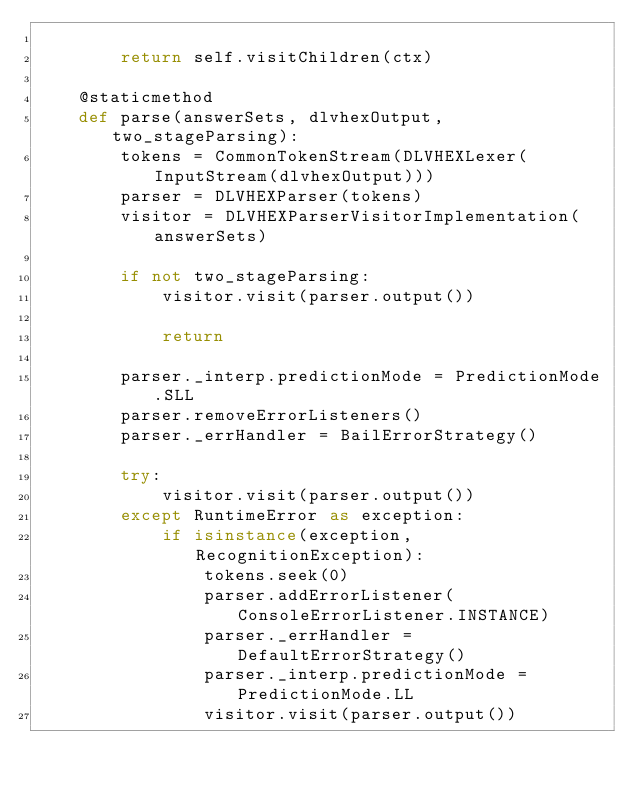Convert code to text. <code><loc_0><loc_0><loc_500><loc_500><_Python_>
        return self.visitChildren(ctx)

    @staticmethod
    def parse(answerSets, dlvhexOutput, two_stageParsing):
        tokens = CommonTokenStream(DLVHEXLexer(InputStream(dlvhexOutput)))
        parser = DLVHEXParser(tokens)
        visitor = DLVHEXParserVisitorImplementation(answerSets)

        if not two_stageParsing:
            visitor.visit(parser.output())

            return

        parser._interp.predictionMode = PredictionMode.SLL
        parser.removeErrorListeners()
        parser._errHandler = BailErrorStrategy()

        try:
            visitor.visit(parser.output())
        except RuntimeError as exception:
            if isinstance(exception, RecognitionException):
                tokens.seek(0)
                parser.addErrorListener(ConsoleErrorListener.INSTANCE)
                parser._errHandler = DefaultErrorStrategy()
                parser._interp.predictionMode = PredictionMode.LL
                visitor.visit(parser.output())
</code> 